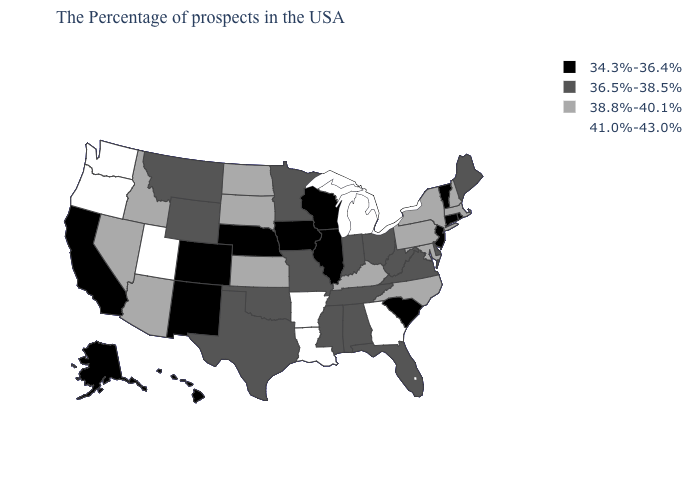What is the value of New Hampshire?
Be succinct. 38.8%-40.1%. What is the lowest value in the USA?
Be succinct. 34.3%-36.4%. What is the value of South Dakota?
Write a very short answer. 38.8%-40.1%. Name the states that have a value in the range 36.5%-38.5%?
Be succinct. Maine, Delaware, Virginia, West Virginia, Ohio, Florida, Indiana, Alabama, Tennessee, Mississippi, Missouri, Minnesota, Oklahoma, Texas, Wyoming, Montana. How many symbols are there in the legend?
Write a very short answer. 4. What is the value of Michigan?
Concise answer only. 41.0%-43.0%. Which states have the lowest value in the MidWest?
Quick response, please. Wisconsin, Illinois, Iowa, Nebraska. Does Mississippi have a higher value than North Dakota?
Concise answer only. No. Name the states that have a value in the range 36.5%-38.5%?
Write a very short answer. Maine, Delaware, Virginia, West Virginia, Ohio, Florida, Indiana, Alabama, Tennessee, Mississippi, Missouri, Minnesota, Oklahoma, Texas, Wyoming, Montana. Does Oregon have the highest value in the USA?
Write a very short answer. Yes. Among the states that border Michigan , does Wisconsin have the lowest value?
Quick response, please. Yes. Name the states that have a value in the range 34.3%-36.4%?
Concise answer only. Rhode Island, Vermont, Connecticut, New Jersey, South Carolina, Wisconsin, Illinois, Iowa, Nebraska, Colorado, New Mexico, California, Alaska, Hawaii. What is the value of North Carolina?
Keep it brief. 38.8%-40.1%. What is the value of Idaho?
Short answer required. 38.8%-40.1%. Does Wyoming have the same value as Indiana?
Short answer required. Yes. 